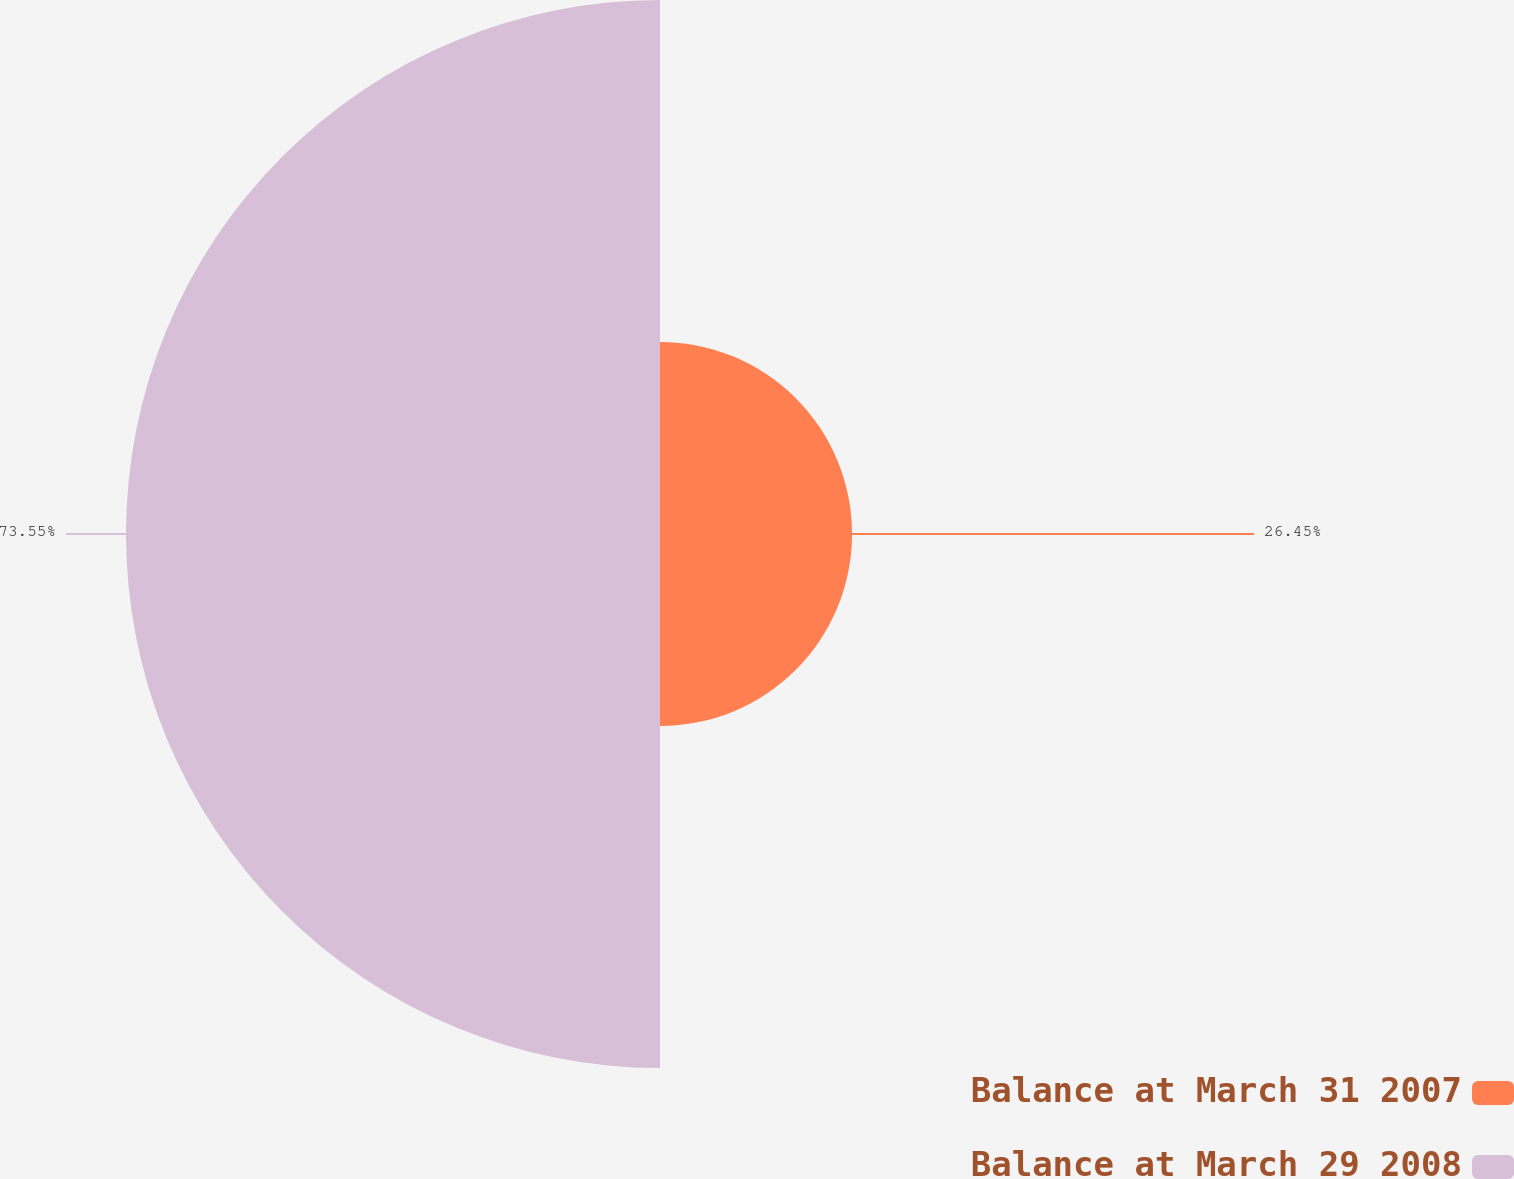Convert chart to OTSL. <chart><loc_0><loc_0><loc_500><loc_500><pie_chart><fcel>Balance at March 31 2007<fcel>Balance at March 29 2008<nl><fcel>26.45%<fcel>73.55%<nl></chart> 